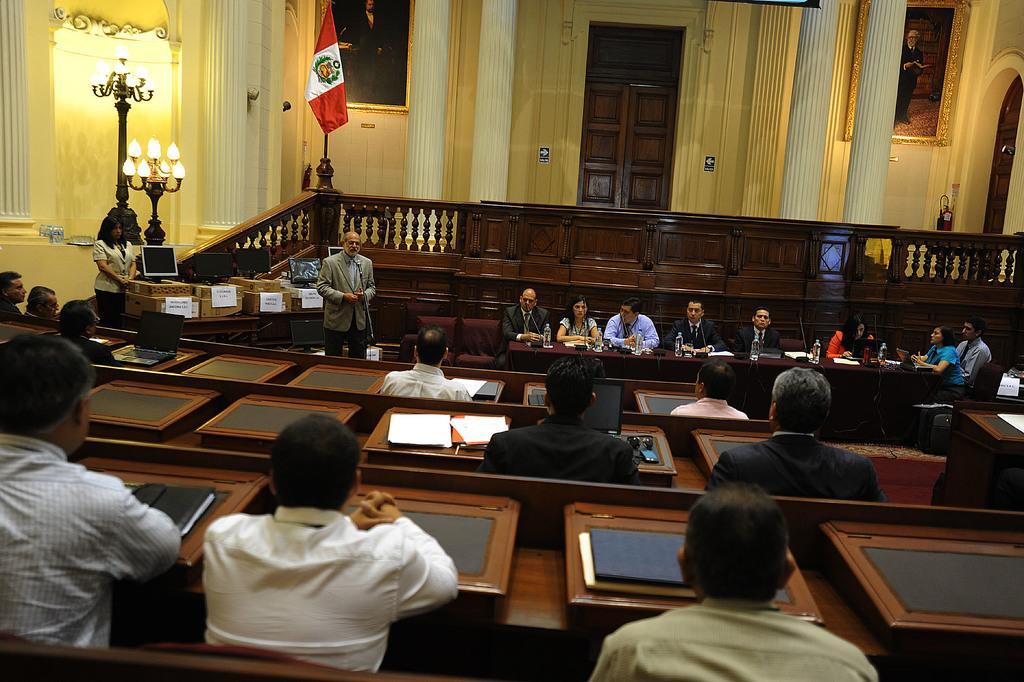Can you describe this image briefly? In this image there are a few people seated in chairs and there are a few objects in front of them, in the background of the image there is a person standing and speaking in front of a mic, beside him there are a few people seated in chairs, in front of them on the table there are mice, papers and bottles of water. On the left of the image there is a woman standing, in front of her there is a monitor and a few boxes on the table, in the background of the image there are lamps, flags, pillars and wooden fence and there is a closed door and there are two photo frames on the wall. 